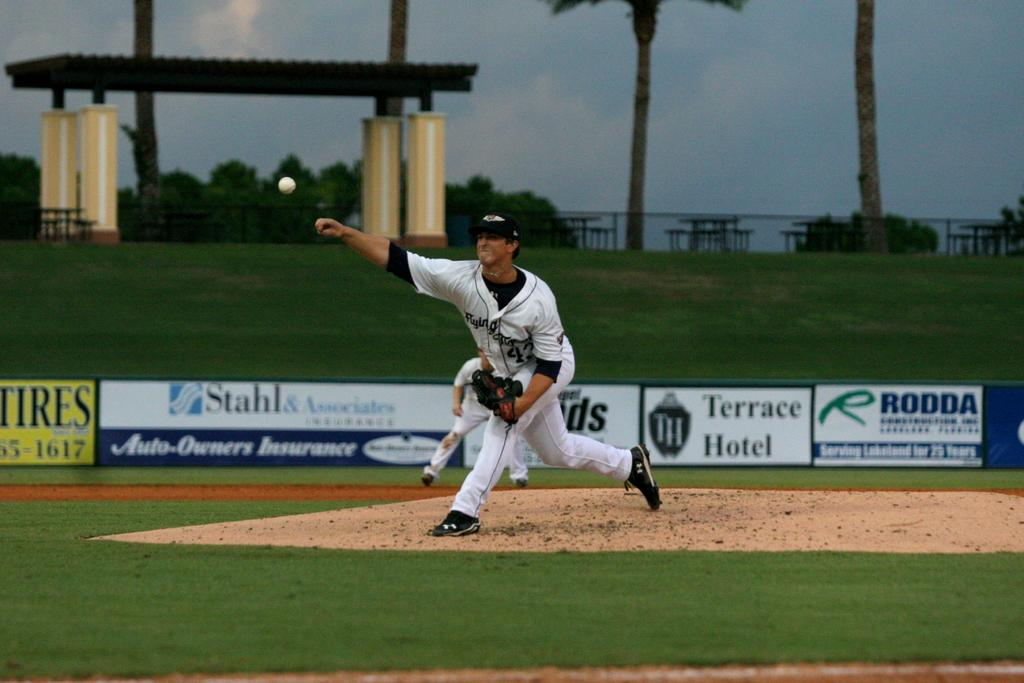<image>
Relay a brief, clear account of the picture shown. a baseball player pitching a ball in front of a sideline banner that says 'terrace hotel' 